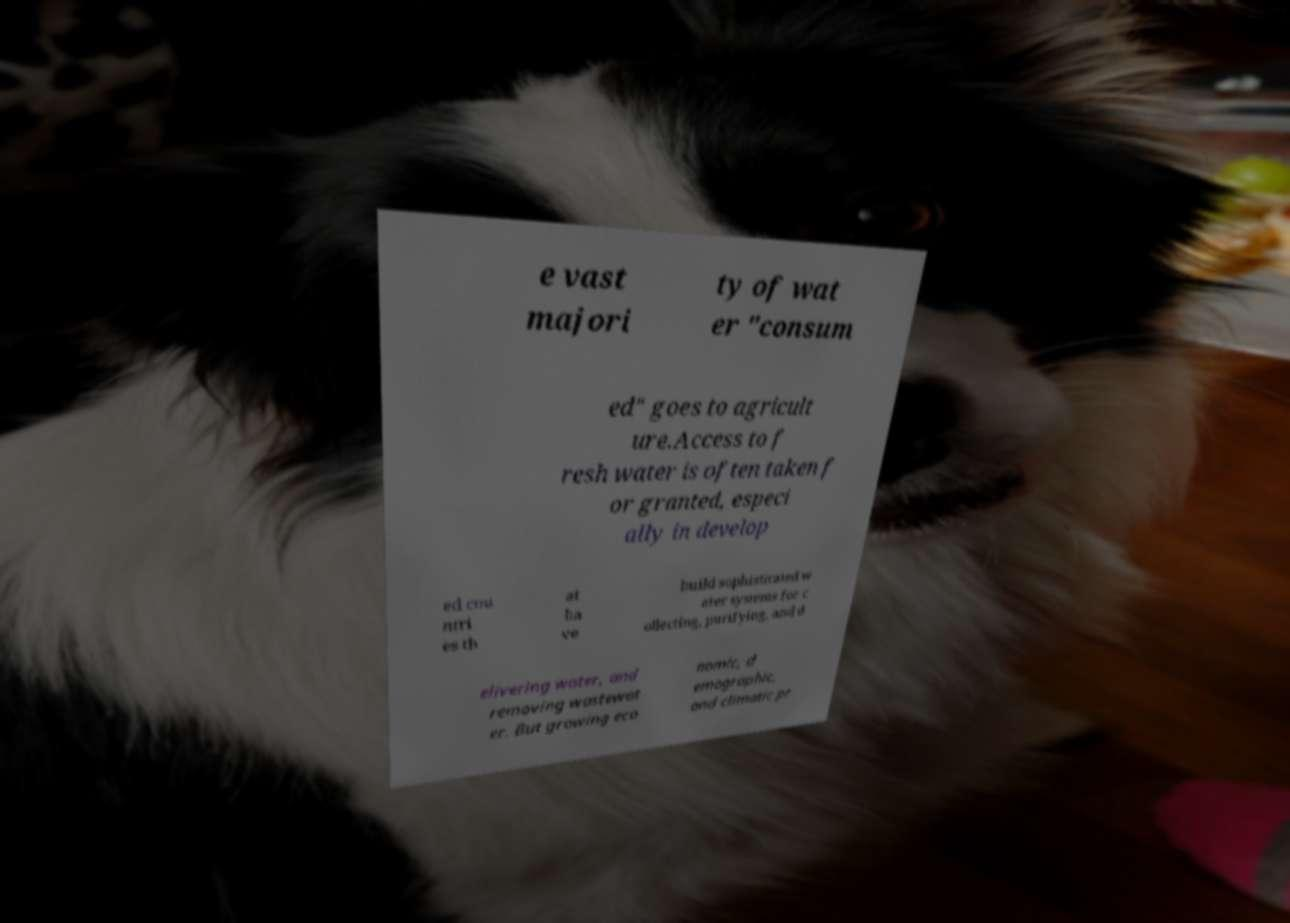For documentation purposes, I need the text within this image transcribed. Could you provide that? e vast majori ty of wat er "consum ed" goes to agricult ure.Access to f resh water is often taken f or granted, especi ally in develop ed cou ntri es th at ha ve build sophisticated w ater systems for c ollecting, purifying, and d elivering water, and removing wastewat er. But growing eco nomic, d emographic, and climatic pr 